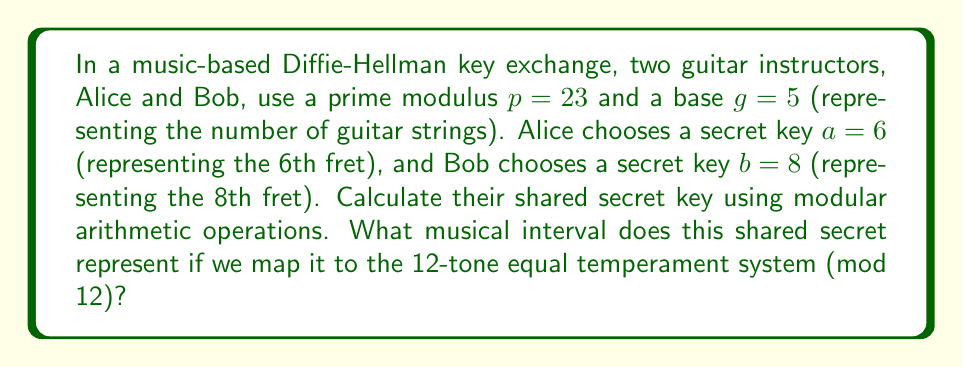Help me with this question. 1) First, we need to calculate Alice's public key:
   $$A \equiv g^a \pmod{p}$$
   $$A \equiv 5^6 \pmod{23}$$
   $$A \equiv 15625 \pmod{23} \equiv 8$$

2) Next, we calculate Bob's public key:
   $$B \equiv g^b \pmod{p}$$
   $$B \equiv 5^8 \pmod{23}$$
   $$B \equiv 390625 \pmod{23} \equiv 16$$

3) Now, Alice computes the shared secret:
   $$s \equiv B^a \pmod{p}$$
   $$s \equiv 16^6 \pmod{23}$$
   $$s \equiv 16777216 \pmod{23} \equiv 9$$

4) Bob computes the same shared secret:
   $$s \equiv A^b \pmod{p}$$
   $$s \equiv 8^8 \pmod{23}$$
   $$s \equiv 16777216 \pmod{23} \equiv 9$$

5) To map this to the 12-tone equal temperament system, we use modulo 12:
   $$9 \pmod{12} \equiv 9$$

6) In the 12-tone system, 9 represents the interval of a major 6th.
Answer: Major 6th 